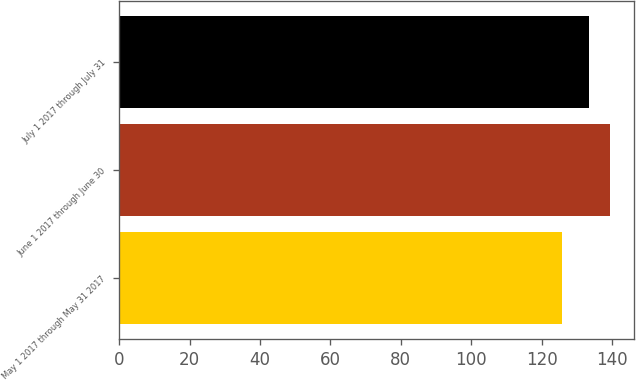<chart> <loc_0><loc_0><loc_500><loc_500><bar_chart><fcel>May 1 2017 through May 31 2017<fcel>June 1 2017 through June 30<fcel>July 1 2017 through July 31<nl><fcel>125.68<fcel>139.33<fcel>133.54<nl></chart> 